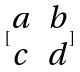<formula> <loc_0><loc_0><loc_500><loc_500>[ \begin{matrix} a & b \\ c & d \\ \end{matrix} ]</formula> 